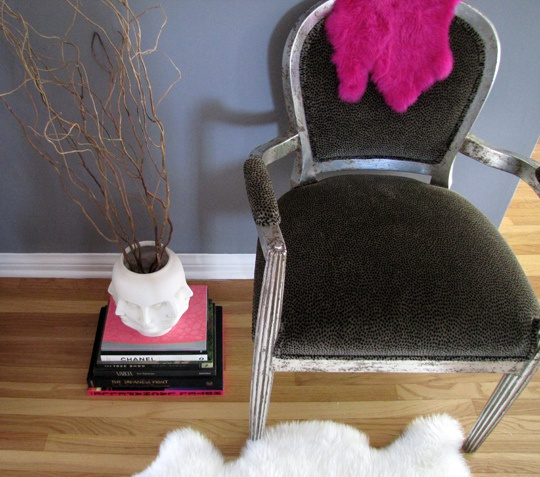Describe the objects in this image and their specific colors. I can see chair in gray, black, darkgray, and lightgray tones, potted plant in gray, lightgray, and black tones, book in gray, black, maroon, and brown tones, vase in gray, lightgray, darkgray, black, and pink tones, and book in gray, salmon, darkgray, and brown tones in this image. 